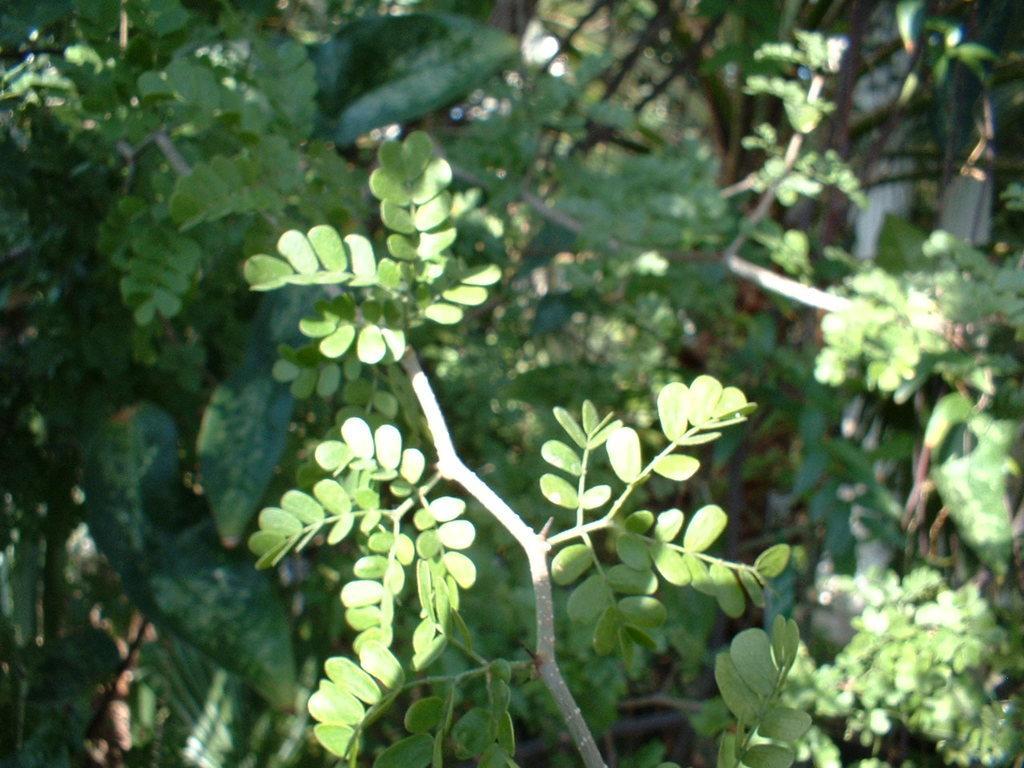Can you describe this image briefly? In this image we can see group of leaves on the stem of a plant. In the background, we can see group of plants. 